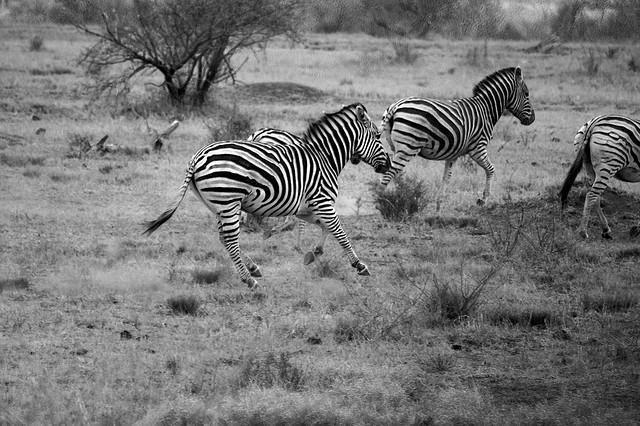How many zebras are there?
Give a very brief answer. 3. How many trains have a number on the front?
Give a very brief answer. 0. 